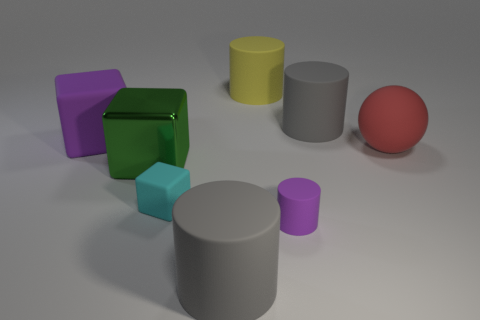Does the small rubber cylinder have the same color as the big rubber block?
Your response must be concise. Yes. What number of objects are large matte cylinders in front of the large ball or cyan metallic objects?
Provide a succinct answer. 1. There is a cyan cube that is the same material as the small purple cylinder; what size is it?
Offer a very short reply. Small. Is the number of large green metal cubes that are right of the purple matte block greater than the number of big red cubes?
Provide a short and direct response. Yes. There is a large metal object; is it the same shape as the big object in front of the small rubber cylinder?
Your answer should be very brief. No. What number of small things are yellow matte cylinders or cylinders?
Your answer should be very brief. 1. There is a matte cube that is the same color as the tiny rubber cylinder; what size is it?
Provide a succinct answer. Large. What color is the tiny rubber object right of the big cylinder that is in front of the large metal block?
Provide a succinct answer. Purple. Does the large red thing have the same material as the gray thing that is in front of the rubber sphere?
Provide a succinct answer. Yes. There is a large gray cylinder that is behind the large purple thing; what is its material?
Your answer should be very brief. Rubber. 